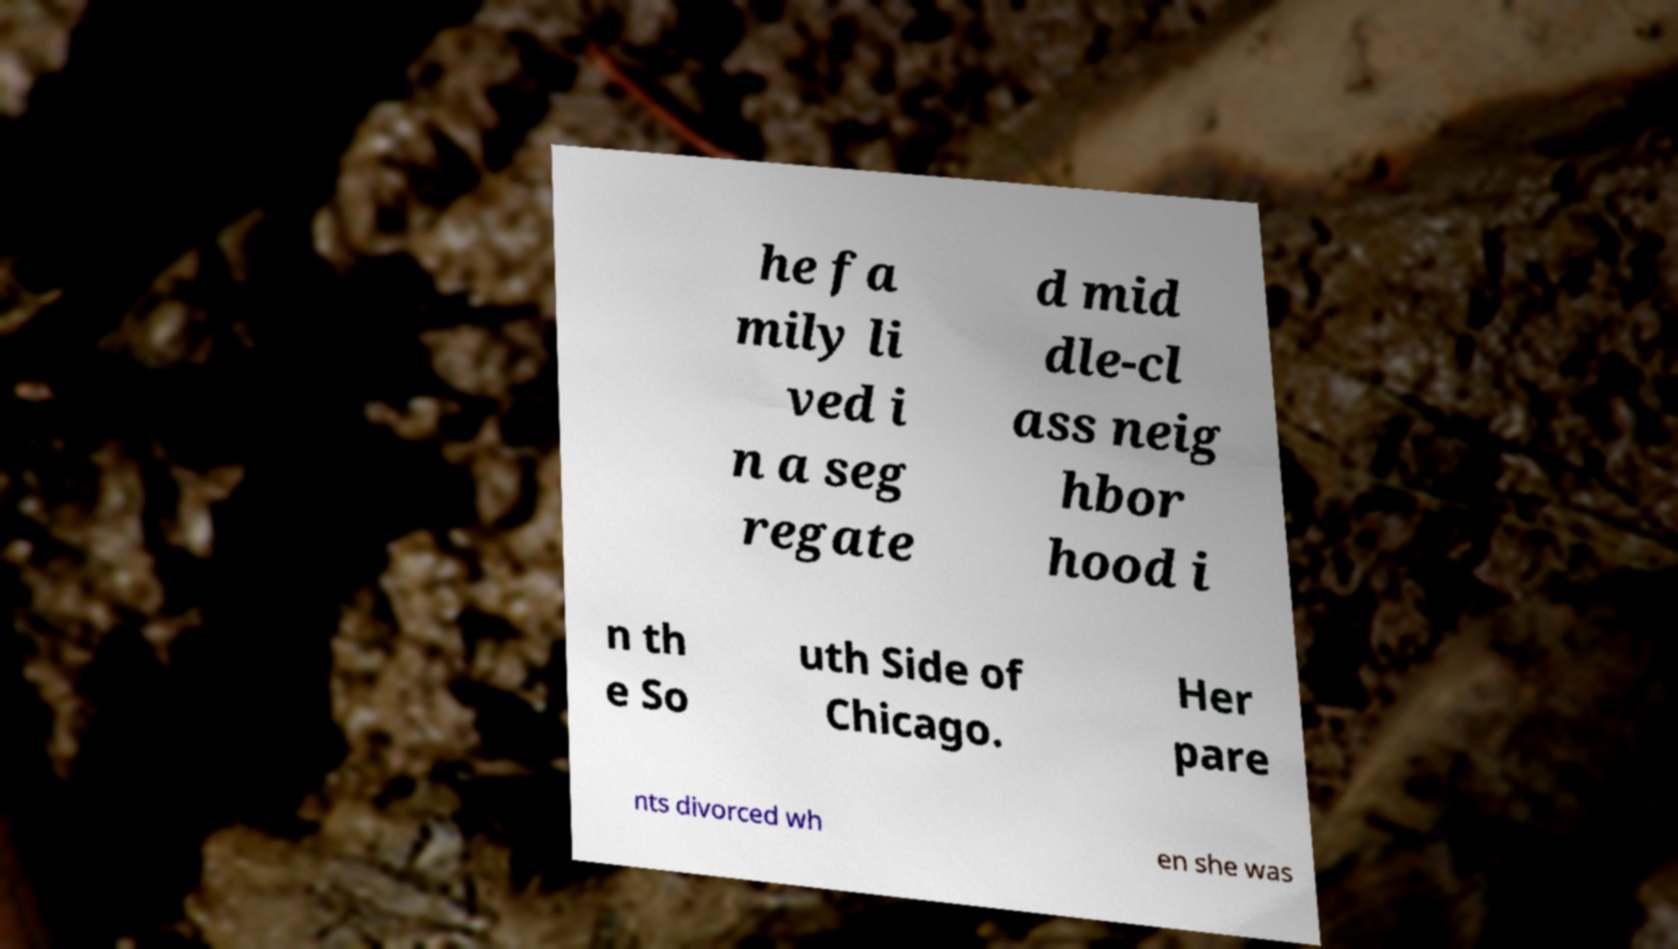Could you assist in decoding the text presented in this image and type it out clearly? he fa mily li ved i n a seg regate d mid dle-cl ass neig hbor hood i n th e So uth Side of Chicago. Her pare nts divorced wh en she was 